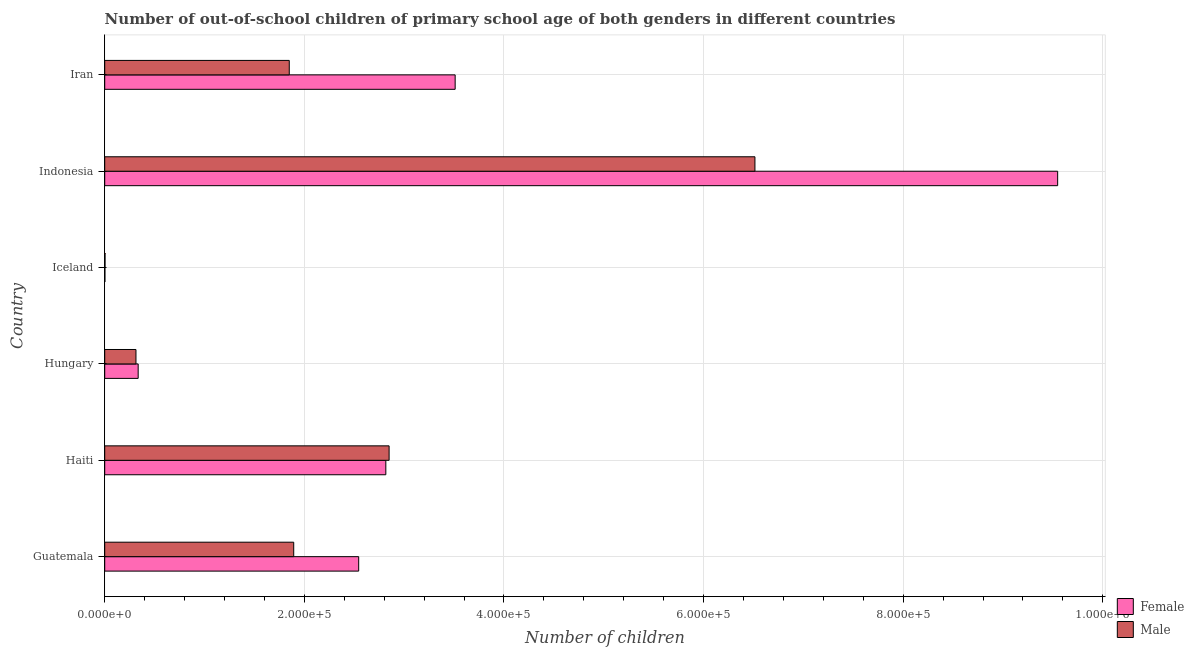How many different coloured bars are there?
Your answer should be very brief. 2. How many groups of bars are there?
Provide a short and direct response. 6. Are the number of bars on each tick of the Y-axis equal?
Keep it short and to the point. Yes. How many bars are there on the 1st tick from the top?
Ensure brevity in your answer.  2. How many bars are there on the 1st tick from the bottom?
Ensure brevity in your answer.  2. What is the label of the 1st group of bars from the top?
Make the answer very short. Iran. In how many cases, is the number of bars for a given country not equal to the number of legend labels?
Ensure brevity in your answer.  0. What is the number of female out-of-school students in Iceland?
Offer a very short reply. 196. Across all countries, what is the maximum number of female out-of-school students?
Your response must be concise. 9.55e+05. Across all countries, what is the minimum number of female out-of-school students?
Give a very brief answer. 196. In which country was the number of female out-of-school students maximum?
Offer a very short reply. Indonesia. In which country was the number of male out-of-school students minimum?
Offer a very short reply. Iceland. What is the total number of male out-of-school students in the graph?
Provide a short and direct response. 1.34e+06. What is the difference between the number of male out-of-school students in Guatemala and that in Iran?
Offer a very short reply. 4470. What is the difference between the number of female out-of-school students in Hungary and the number of male out-of-school students in Haiti?
Provide a succinct answer. -2.51e+05. What is the average number of female out-of-school students per country?
Provide a short and direct response. 3.13e+05. What is the difference between the number of female out-of-school students and number of male out-of-school students in Haiti?
Keep it short and to the point. -3279. What is the ratio of the number of male out-of-school students in Guatemala to that in Indonesia?
Keep it short and to the point. 0.29. Is the difference between the number of female out-of-school students in Guatemala and Indonesia greater than the difference between the number of male out-of-school students in Guatemala and Indonesia?
Offer a very short reply. No. What is the difference between the highest and the second highest number of female out-of-school students?
Your answer should be very brief. 6.04e+05. What is the difference between the highest and the lowest number of male out-of-school students?
Give a very brief answer. 6.51e+05. Is the sum of the number of male out-of-school students in Haiti and Iran greater than the maximum number of female out-of-school students across all countries?
Give a very brief answer. No. What does the 1st bar from the top in Indonesia represents?
Give a very brief answer. Male. What does the 2nd bar from the bottom in Indonesia represents?
Ensure brevity in your answer.  Male. How many bars are there?
Your answer should be very brief. 12. Are all the bars in the graph horizontal?
Keep it short and to the point. Yes. How many countries are there in the graph?
Offer a very short reply. 6. Does the graph contain any zero values?
Offer a terse response. No. Does the graph contain grids?
Provide a short and direct response. Yes. How many legend labels are there?
Offer a terse response. 2. How are the legend labels stacked?
Ensure brevity in your answer.  Vertical. What is the title of the graph?
Ensure brevity in your answer.  Number of out-of-school children of primary school age of both genders in different countries. What is the label or title of the X-axis?
Give a very brief answer. Number of children. What is the label or title of the Y-axis?
Provide a succinct answer. Country. What is the Number of children in Female in Guatemala?
Provide a short and direct response. 2.54e+05. What is the Number of children of Male in Guatemala?
Keep it short and to the point. 1.89e+05. What is the Number of children in Female in Haiti?
Give a very brief answer. 2.82e+05. What is the Number of children in Male in Haiti?
Give a very brief answer. 2.85e+05. What is the Number of children in Female in Hungary?
Provide a succinct answer. 3.35e+04. What is the Number of children in Male in Hungary?
Make the answer very short. 3.13e+04. What is the Number of children of Female in Iceland?
Make the answer very short. 196. What is the Number of children in Male in Iceland?
Keep it short and to the point. 319. What is the Number of children in Female in Indonesia?
Your answer should be compact. 9.55e+05. What is the Number of children in Male in Indonesia?
Ensure brevity in your answer.  6.51e+05. What is the Number of children in Female in Iran?
Your answer should be compact. 3.51e+05. What is the Number of children in Male in Iran?
Make the answer very short. 1.85e+05. Across all countries, what is the maximum Number of children of Female?
Provide a short and direct response. 9.55e+05. Across all countries, what is the maximum Number of children in Male?
Offer a very short reply. 6.51e+05. Across all countries, what is the minimum Number of children of Female?
Provide a succinct answer. 196. Across all countries, what is the minimum Number of children of Male?
Your answer should be compact. 319. What is the total Number of children in Female in the graph?
Offer a very short reply. 1.88e+06. What is the total Number of children of Male in the graph?
Your answer should be compact. 1.34e+06. What is the difference between the Number of children of Female in Guatemala and that in Haiti?
Provide a succinct answer. -2.72e+04. What is the difference between the Number of children of Male in Guatemala and that in Haiti?
Offer a very short reply. -9.56e+04. What is the difference between the Number of children in Female in Guatemala and that in Hungary?
Offer a terse response. 2.21e+05. What is the difference between the Number of children of Male in Guatemala and that in Hungary?
Your answer should be compact. 1.58e+05. What is the difference between the Number of children in Female in Guatemala and that in Iceland?
Make the answer very short. 2.54e+05. What is the difference between the Number of children of Male in Guatemala and that in Iceland?
Provide a short and direct response. 1.89e+05. What is the difference between the Number of children of Female in Guatemala and that in Indonesia?
Provide a short and direct response. -7.00e+05. What is the difference between the Number of children in Male in Guatemala and that in Indonesia?
Offer a terse response. -4.62e+05. What is the difference between the Number of children of Female in Guatemala and that in Iran?
Your answer should be compact. -9.67e+04. What is the difference between the Number of children of Male in Guatemala and that in Iran?
Offer a terse response. 4470. What is the difference between the Number of children in Female in Haiti and that in Hungary?
Give a very brief answer. 2.48e+05. What is the difference between the Number of children in Male in Haiti and that in Hungary?
Offer a very short reply. 2.54e+05. What is the difference between the Number of children in Female in Haiti and that in Iceland?
Your answer should be compact. 2.81e+05. What is the difference between the Number of children in Male in Haiti and that in Iceland?
Give a very brief answer. 2.85e+05. What is the difference between the Number of children of Female in Haiti and that in Indonesia?
Make the answer very short. -6.73e+05. What is the difference between the Number of children in Male in Haiti and that in Indonesia?
Offer a terse response. -3.67e+05. What is the difference between the Number of children in Female in Haiti and that in Iran?
Provide a short and direct response. -6.95e+04. What is the difference between the Number of children of Male in Haiti and that in Iran?
Ensure brevity in your answer.  1.00e+05. What is the difference between the Number of children of Female in Hungary and that in Iceland?
Your answer should be very brief. 3.33e+04. What is the difference between the Number of children in Male in Hungary and that in Iceland?
Provide a succinct answer. 3.10e+04. What is the difference between the Number of children of Female in Hungary and that in Indonesia?
Give a very brief answer. -9.21e+05. What is the difference between the Number of children in Male in Hungary and that in Indonesia?
Offer a very short reply. -6.20e+05. What is the difference between the Number of children of Female in Hungary and that in Iran?
Offer a very short reply. -3.18e+05. What is the difference between the Number of children of Male in Hungary and that in Iran?
Keep it short and to the point. -1.54e+05. What is the difference between the Number of children in Female in Iceland and that in Indonesia?
Your answer should be very brief. -9.55e+05. What is the difference between the Number of children in Male in Iceland and that in Indonesia?
Provide a succinct answer. -6.51e+05. What is the difference between the Number of children of Female in Iceland and that in Iran?
Offer a terse response. -3.51e+05. What is the difference between the Number of children in Male in Iceland and that in Iran?
Provide a short and direct response. -1.85e+05. What is the difference between the Number of children in Female in Indonesia and that in Iran?
Your answer should be very brief. 6.04e+05. What is the difference between the Number of children in Male in Indonesia and that in Iran?
Make the answer very short. 4.67e+05. What is the difference between the Number of children of Female in Guatemala and the Number of children of Male in Haiti?
Your answer should be very brief. -3.05e+04. What is the difference between the Number of children of Female in Guatemala and the Number of children of Male in Hungary?
Ensure brevity in your answer.  2.23e+05. What is the difference between the Number of children in Female in Guatemala and the Number of children in Male in Iceland?
Make the answer very short. 2.54e+05. What is the difference between the Number of children in Female in Guatemala and the Number of children in Male in Indonesia?
Your response must be concise. -3.97e+05. What is the difference between the Number of children in Female in Guatemala and the Number of children in Male in Iran?
Your answer should be compact. 6.96e+04. What is the difference between the Number of children of Female in Haiti and the Number of children of Male in Hungary?
Ensure brevity in your answer.  2.50e+05. What is the difference between the Number of children in Female in Haiti and the Number of children in Male in Iceland?
Your answer should be compact. 2.81e+05. What is the difference between the Number of children in Female in Haiti and the Number of children in Male in Indonesia?
Make the answer very short. -3.70e+05. What is the difference between the Number of children in Female in Haiti and the Number of children in Male in Iran?
Provide a succinct answer. 9.68e+04. What is the difference between the Number of children in Female in Hungary and the Number of children in Male in Iceland?
Keep it short and to the point. 3.32e+04. What is the difference between the Number of children in Female in Hungary and the Number of children in Male in Indonesia?
Give a very brief answer. -6.18e+05. What is the difference between the Number of children of Female in Hungary and the Number of children of Male in Iran?
Offer a terse response. -1.51e+05. What is the difference between the Number of children in Female in Iceland and the Number of children in Male in Indonesia?
Give a very brief answer. -6.51e+05. What is the difference between the Number of children in Female in Iceland and the Number of children in Male in Iran?
Your response must be concise. -1.85e+05. What is the difference between the Number of children of Female in Indonesia and the Number of children of Male in Iran?
Your answer should be compact. 7.70e+05. What is the average Number of children of Female per country?
Provide a short and direct response. 3.13e+05. What is the average Number of children of Male per country?
Provide a succinct answer. 2.24e+05. What is the difference between the Number of children of Female and Number of children of Male in Guatemala?
Provide a succinct answer. 6.51e+04. What is the difference between the Number of children in Female and Number of children in Male in Haiti?
Your answer should be very brief. -3279. What is the difference between the Number of children of Female and Number of children of Male in Hungary?
Offer a very short reply. 2213. What is the difference between the Number of children in Female and Number of children in Male in Iceland?
Provide a short and direct response. -123. What is the difference between the Number of children in Female and Number of children in Male in Indonesia?
Your response must be concise. 3.03e+05. What is the difference between the Number of children of Female and Number of children of Male in Iran?
Offer a very short reply. 1.66e+05. What is the ratio of the Number of children of Female in Guatemala to that in Haiti?
Provide a short and direct response. 0.9. What is the ratio of the Number of children in Male in Guatemala to that in Haiti?
Your response must be concise. 0.66. What is the ratio of the Number of children of Female in Guatemala to that in Hungary?
Provide a succinct answer. 7.59. What is the ratio of the Number of children in Male in Guatemala to that in Hungary?
Offer a terse response. 6.05. What is the ratio of the Number of children in Female in Guatemala to that in Iceland?
Your response must be concise. 1298.26. What is the ratio of the Number of children of Male in Guatemala to that in Iceland?
Your answer should be compact. 593.63. What is the ratio of the Number of children in Female in Guatemala to that in Indonesia?
Offer a very short reply. 0.27. What is the ratio of the Number of children of Male in Guatemala to that in Indonesia?
Your response must be concise. 0.29. What is the ratio of the Number of children of Female in Guatemala to that in Iran?
Offer a terse response. 0.72. What is the ratio of the Number of children in Male in Guatemala to that in Iran?
Provide a succinct answer. 1.02. What is the ratio of the Number of children in Female in Haiti to that in Hungary?
Ensure brevity in your answer.  8.4. What is the ratio of the Number of children of Male in Haiti to that in Hungary?
Offer a very short reply. 9.1. What is the ratio of the Number of children of Female in Haiti to that in Iceland?
Provide a short and direct response. 1436.99. What is the ratio of the Number of children of Male in Haiti to that in Iceland?
Give a very brief answer. 893.19. What is the ratio of the Number of children of Female in Haiti to that in Indonesia?
Your response must be concise. 0.29. What is the ratio of the Number of children in Male in Haiti to that in Indonesia?
Provide a short and direct response. 0.44. What is the ratio of the Number of children in Female in Haiti to that in Iran?
Offer a very short reply. 0.8. What is the ratio of the Number of children in Male in Haiti to that in Iran?
Your answer should be very brief. 1.54. What is the ratio of the Number of children in Female in Hungary to that in Iceland?
Offer a terse response. 171. What is the ratio of the Number of children in Male in Hungary to that in Iceland?
Your answer should be compact. 98.13. What is the ratio of the Number of children in Female in Hungary to that in Indonesia?
Give a very brief answer. 0.04. What is the ratio of the Number of children in Male in Hungary to that in Indonesia?
Keep it short and to the point. 0.05. What is the ratio of the Number of children in Female in Hungary to that in Iran?
Ensure brevity in your answer.  0.1. What is the ratio of the Number of children of Male in Hungary to that in Iran?
Offer a very short reply. 0.17. What is the ratio of the Number of children in Female in Iceland to that in Indonesia?
Give a very brief answer. 0. What is the ratio of the Number of children in Male in Iceland to that in Indonesia?
Give a very brief answer. 0. What is the ratio of the Number of children of Female in Iceland to that in Iran?
Provide a short and direct response. 0. What is the ratio of the Number of children in Male in Iceland to that in Iran?
Your answer should be compact. 0. What is the ratio of the Number of children of Female in Indonesia to that in Iran?
Your response must be concise. 2.72. What is the ratio of the Number of children of Male in Indonesia to that in Iran?
Offer a terse response. 3.52. What is the difference between the highest and the second highest Number of children of Female?
Ensure brevity in your answer.  6.04e+05. What is the difference between the highest and the second highest Number of children in Male?
Offer a very short reply. 3.67e+05. What is the difference between the highest and the lowest Number of children of Female?
Offer a terse response. 9.55e+05. What is the difference between the highest and the lowest Number of children in Male?
Make the answer very short. 6.51e+05. 